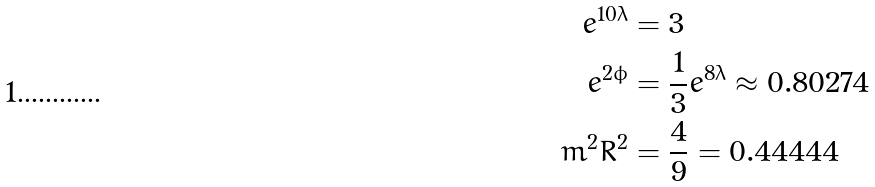Convert formula to latex. <formula><loc_0><loc_0><loc_500><loc_500>e ^ { 1 0 \lambda } & = 3 \\ e ^ { 2 \phi } & = \frac { 1 } { 3 } e ^ { 8 \lambda } \approx 0 . 8 0 2 7 4 \\ m ^ { 2 } R ^ { 2 } & = \frac { 4 } { 9 } = 0 . 4 4 4 4 4</formula> 